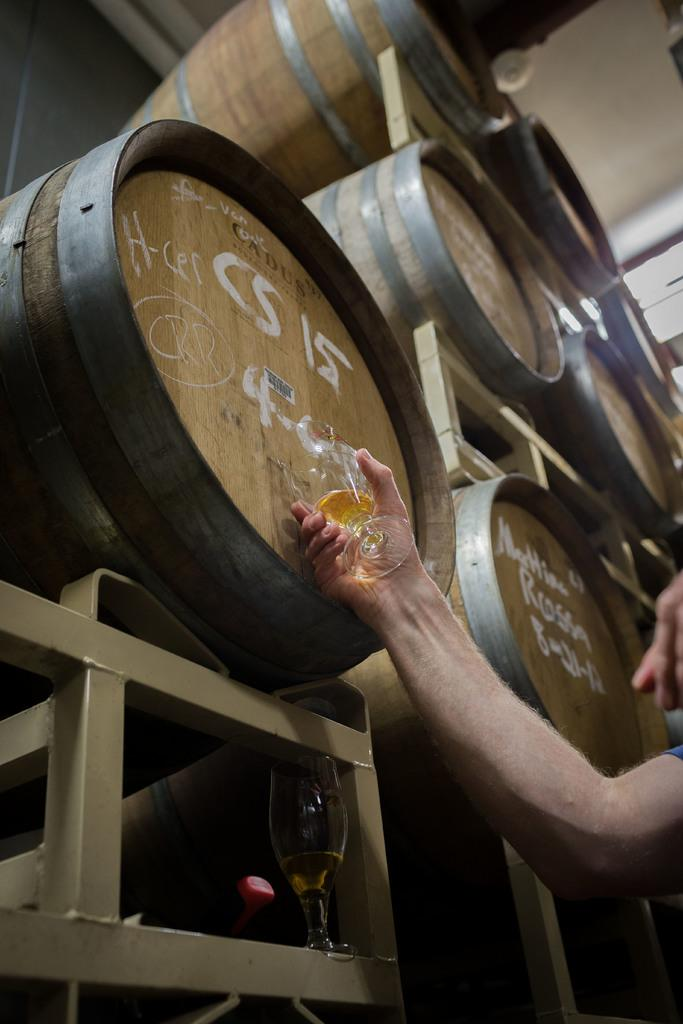Provide a one-sentence caption for the provided image. Snifter being filled from a barrel with the label CS 15 on it, while empty snifter sits below barrel after having been 1/7th filled. 